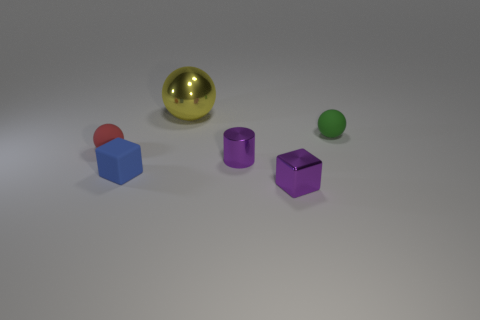Subtract all tiny red spheres. How many spheres are left? 2 Add 3 red matte cylinders. How many objects exist? 9 Subtract 1 cylinders. How many cylinders are left? 0 Subtract all green balls. How many balls are left? 2 Add 3 small shiny cubes. How many small shiny cubes are left? 4 Add 6 cylinders. How many cylinders exist? 7 Subtract 1 green spheres. How many objects are left? 5 Subtract all blocks. How many objects are left? 4 Subtract all yellow cylinders. Subtract all yellow cubes. How many cylinders are left? 1 Subtract all gray cubes. How many red spheres are left? 1 